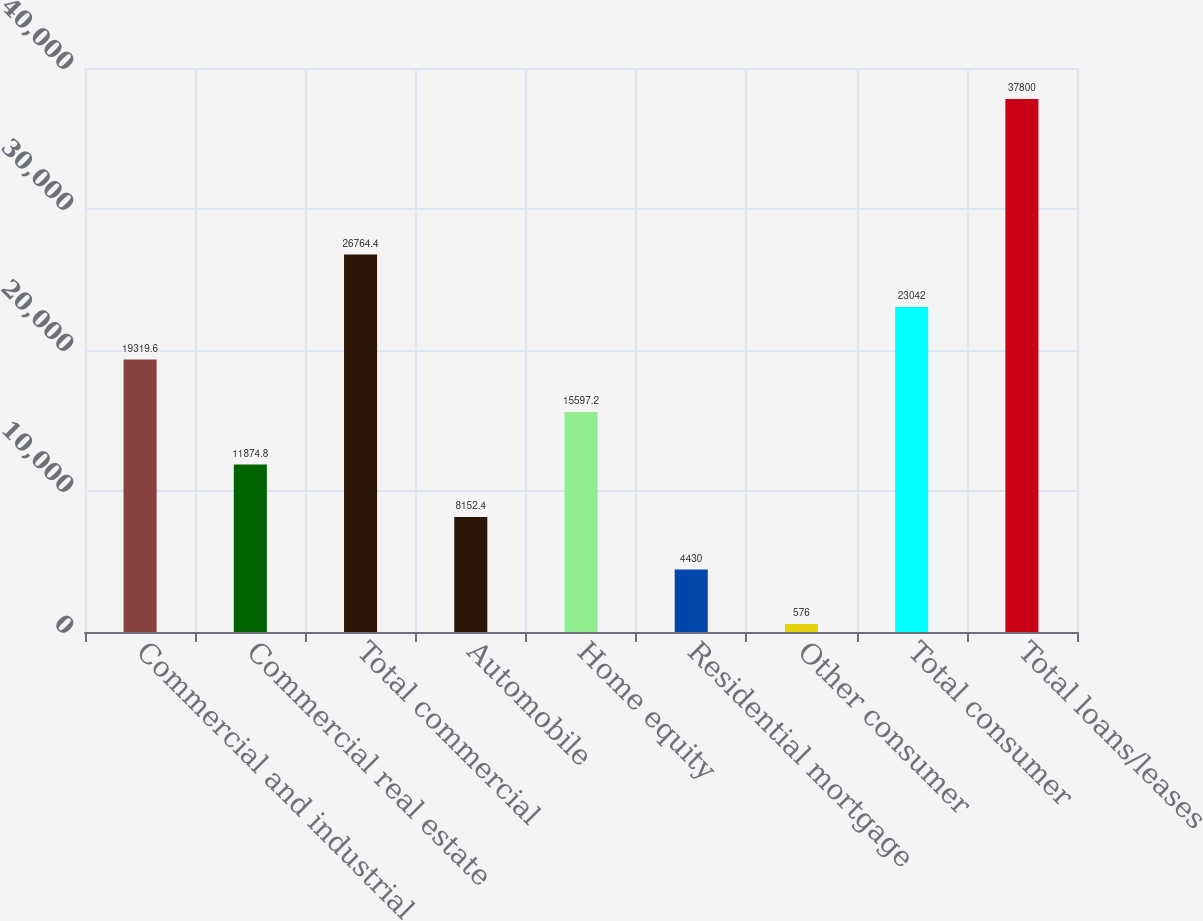<chart> <loc_0><loc_0><loc_500><loc_500><bar_chart><fcel>Commercial and industrial<fcel>Commercial real estate<fcel>Total commercial<fcel>Automobile<fcel>Home equity<fcel>Residential mortgage<fcel>Other consumer<fcel>Total consumer<fcel>Total loans/leases<nl><fcel>19319.6<fcel>11874.8<fcel>26764.4<fcel>8152.4<fcel>15597.2<fcel>4430<fcel>576<fcel>23042<fcel>37800<nl></chart> 